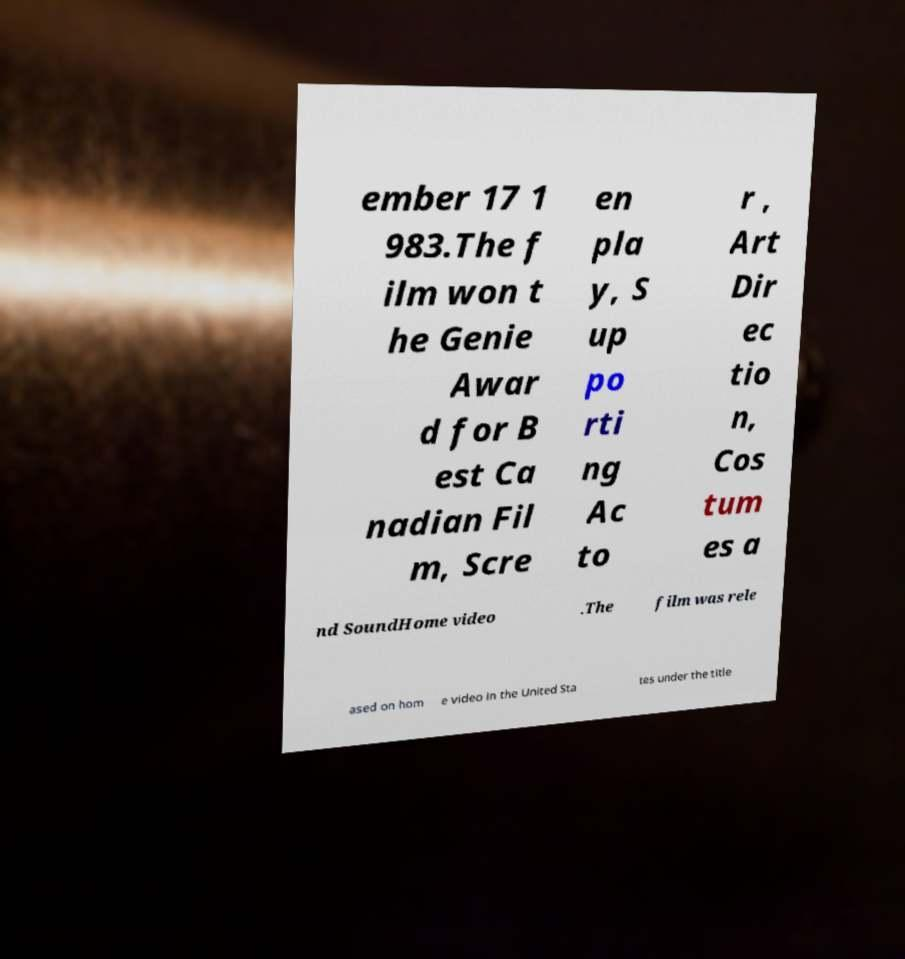Can you read and provide the text displayed in the image?This photo seems to have some interesting text. Can you extract and type it out for me? ember 17 1 983.The f ilm won t he Genie Awar d for B est Ca nadian Fil m, Scre en pla y, S up po rti ng Ac to r , Art Dir ec tio n, Cos tum es a nd SoundHome video .The film was rele ased on hom e video in the United Sta tes under the title 